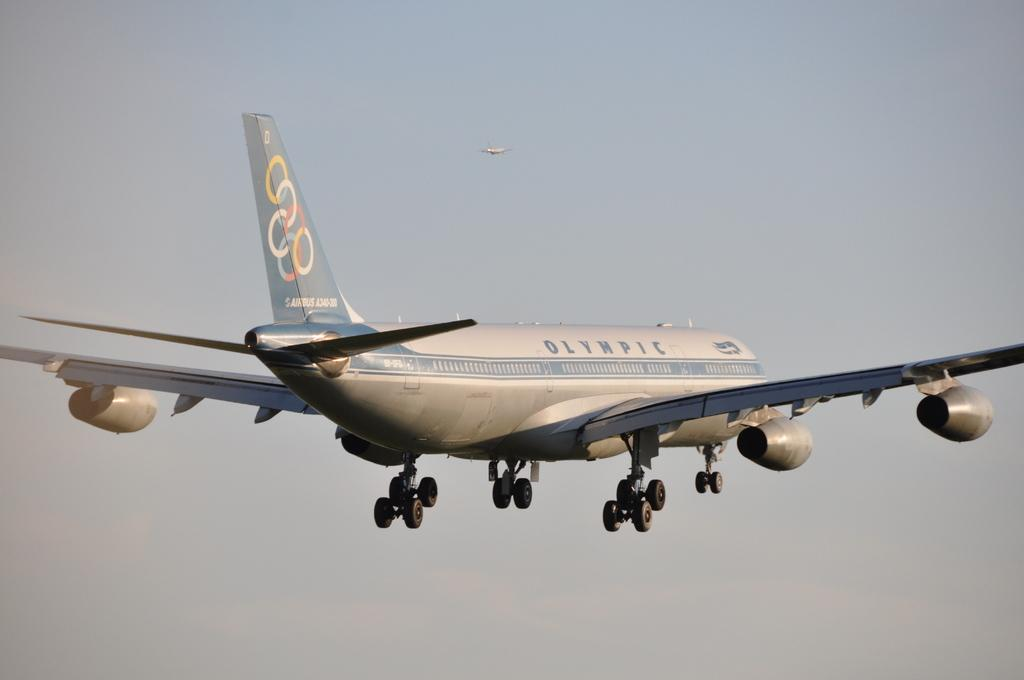What is the main subject of the image? The main subject of the image is a flight. What can be seen on the flight? Something is written on the flight, and there is a logo on it. What is visible in the background of the image? There is sky visible in the background of the image. How many flights are present in the image? There are two flights in the image. What type of ornament is hanging from the flight in the image? There is no ornament hanging from the flight in the image. How many bites have been taken out of the pie in the image? There is no pie present in the image. 